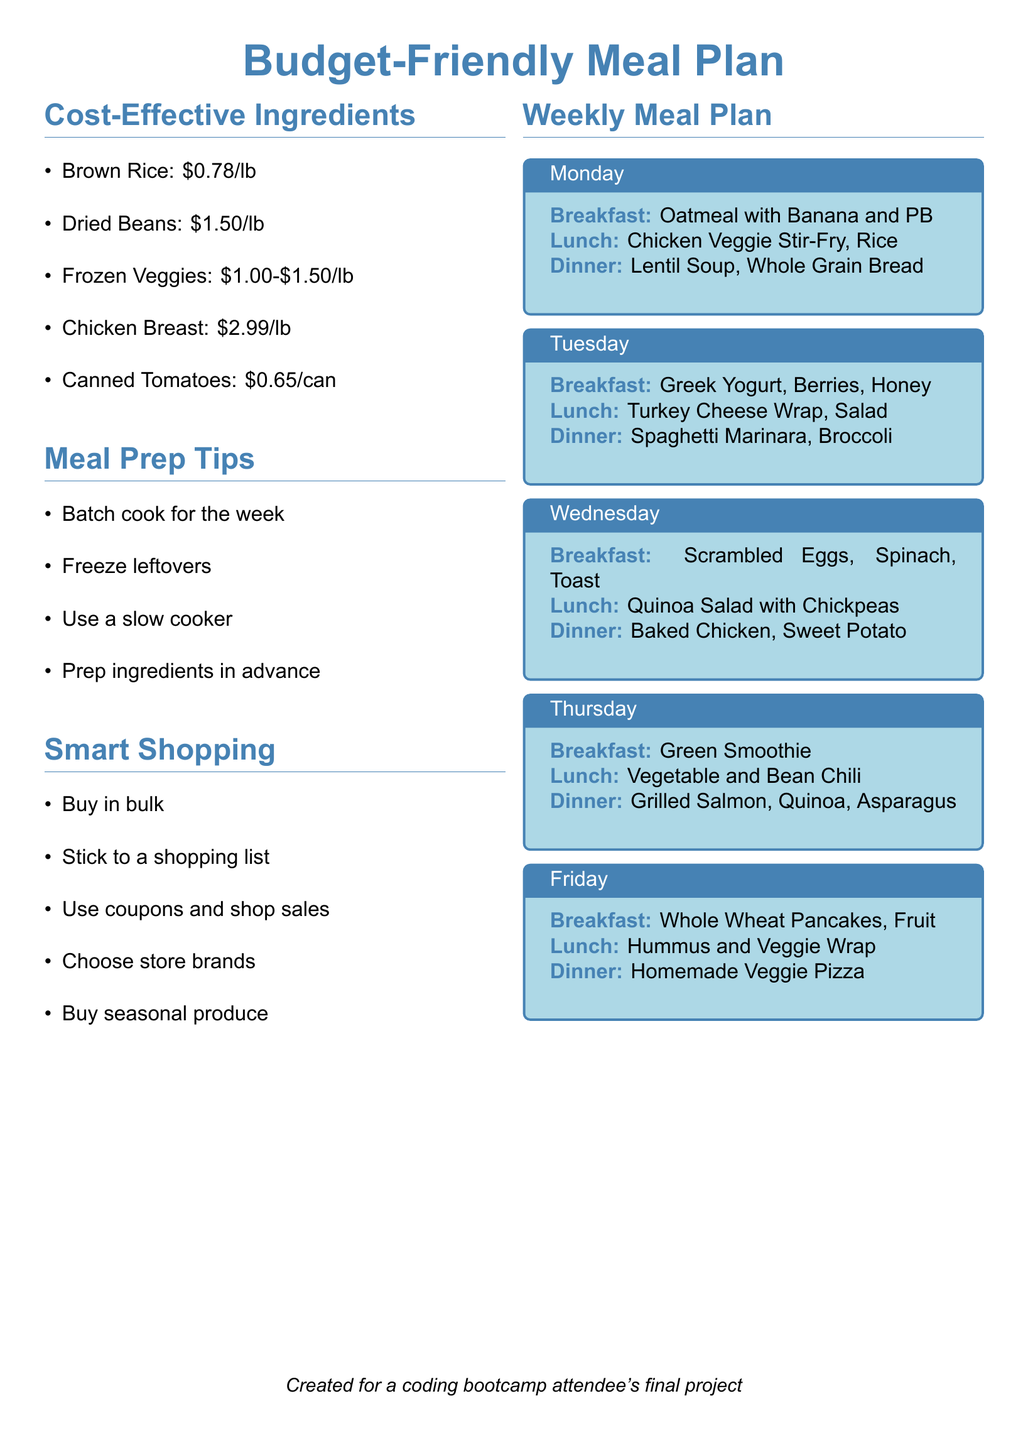What is the cost of brown rice? The cost of brown rice is specifically mentioned in the document.
Answer: $0.78/lb What meal is suggested for breakfast on Tuesday? The document provides a daily breakdown of meals, including breakfast on Tuesday.
Answer: Greek Yogurt, Berries, Honey How much does a can of tomatoes cost? The document lists the price of canned tomatoes as part of the cost-effective ingredients.
Answer: $0.65/can What meal prep technique involves cooking large quantities at once? In the meal prep tips section, one of the methods is described as cooking in large amounts.
Answer: Batch cook for the week Which ingredient is listed as the most expensive at $2.99 per pound? The document mentions several ingredients with their prices, including chicken breast.
Answer: Chicken Breast What is one smart shopping strategy mentioned in the document? The document offers various strategies for smart shopping; one of them is explicitly outlined.
Answer: Buy in bulk What is the dinner option for Thursday? The document specifies a dinner choice for each day of the week, including Thursday.
Answer: Grilled Salmon, Quinoa, Asparagus What type of meal is included in the Friday lunch? The document lists various meals, including the type of lunch for Friday.
Answer: Hummus and Veggie Wrap 